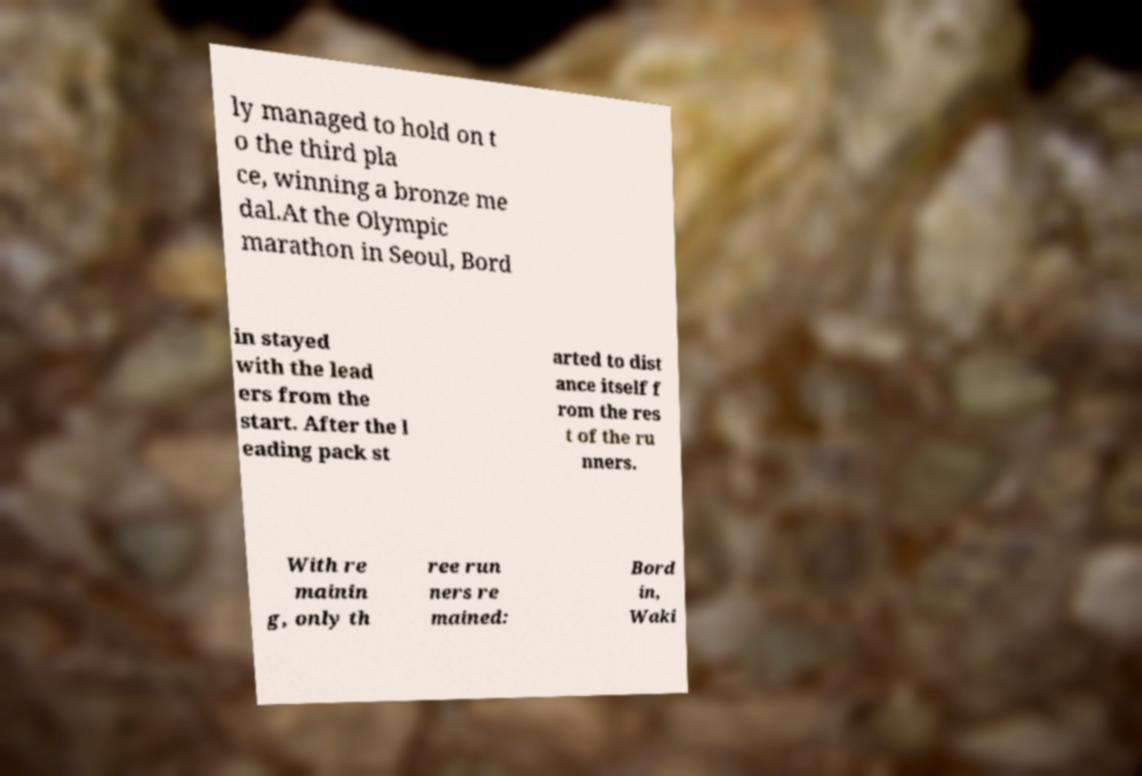Could you assist in decoding the text presented in this image and type it out clearly? ly managed to hold on t o the third pla ce, winning a bronze me dal.At the Olympic marathon in Seoul, Bord in stayed with the lead ers from the start. After the l eading pack st arted to dist ance itself f rom the res t of the ru nners. With re mainin g, only th ree run ners re mained: Bord in, Waki 